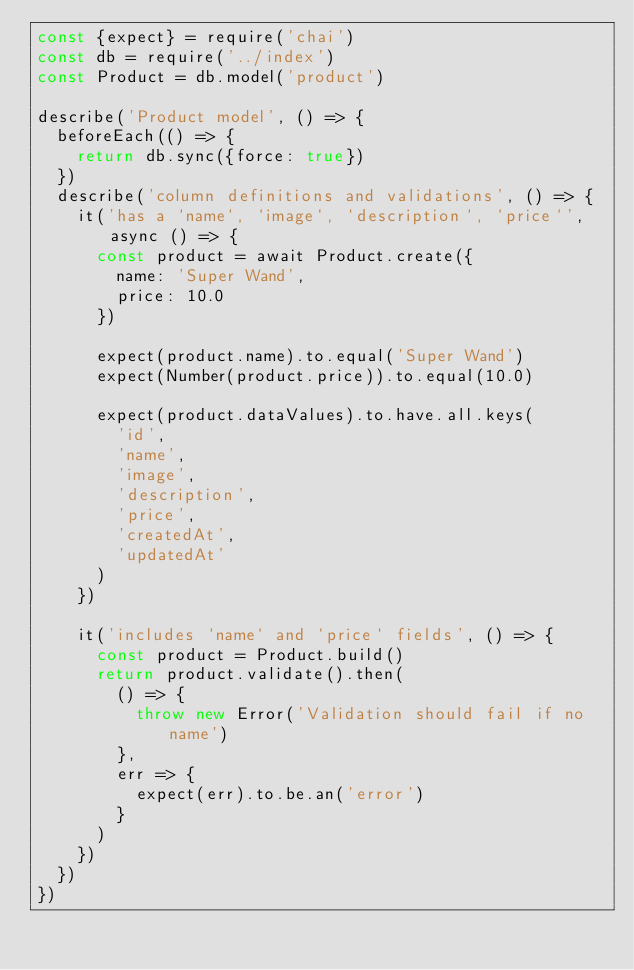Convert code to text. <code><loc_0><loc_0><loc_500><loc_500><_JavaScript_>const {expect} = require('chai')
const db = require('../index')
const Product = db.model('product')

describe('Product model', () => {
  beforeEach(() => {
    return db.sync({force: true})
  })
  describe('column definitions and validations', () => {
    it('has a `name`, `image`, `description`, `price`', async () => {
      const product = await Product.create({
        name: 'Super Wand',
        price: 10.0
      })

      expect(product.name).to.equal('Super Wand')
      expect(Number(product.price)).to.equal(10.0)

      expect(product.dataValues).to.have.all.keys(
        'id',
        'name',
        'image',
        'description',
        'price',
        'createdAt',
        'updatedAt'
      )
    })

    it('includes `name` and `price` fields', () => {
      const product = Product.build()
      return product.validate().then(
        () => {
          throw new Error('Validation should fail if no name')
        },
        err => {
          expect(err).to.be.an('error')
        }
      )
    })
  })
})
</code> 